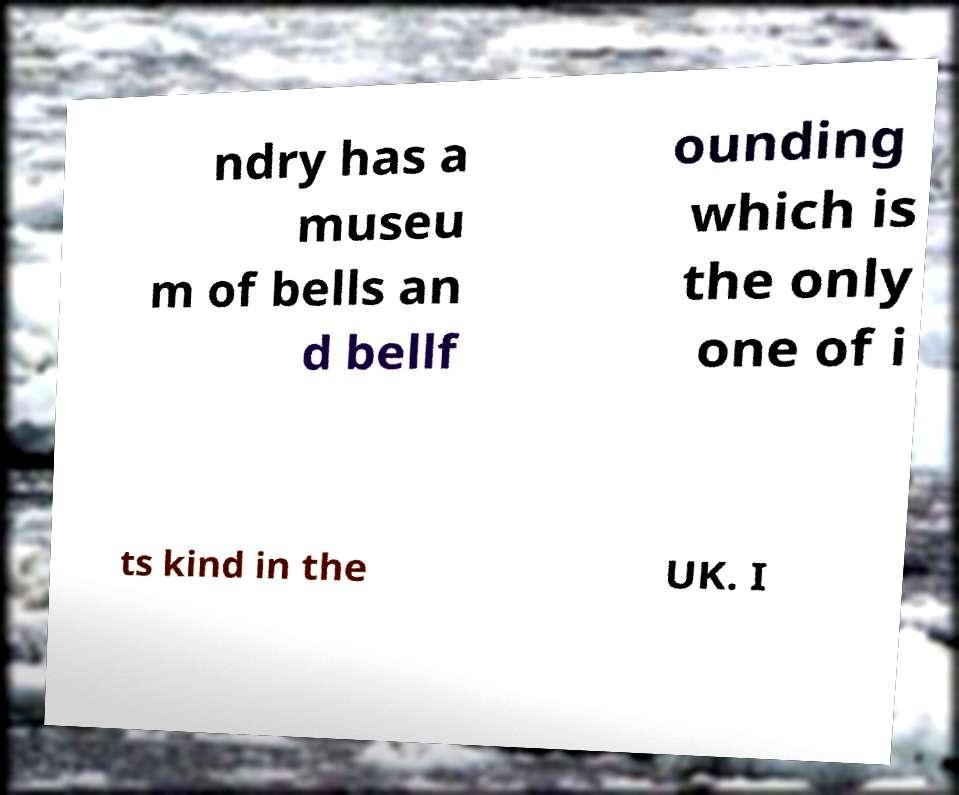There's text embedded in this image that I need extracted. Can you transcribe it verbatim? ndry has a museu m of bells an d bellf ounding which is the only one of i ts kind in the UK. I 